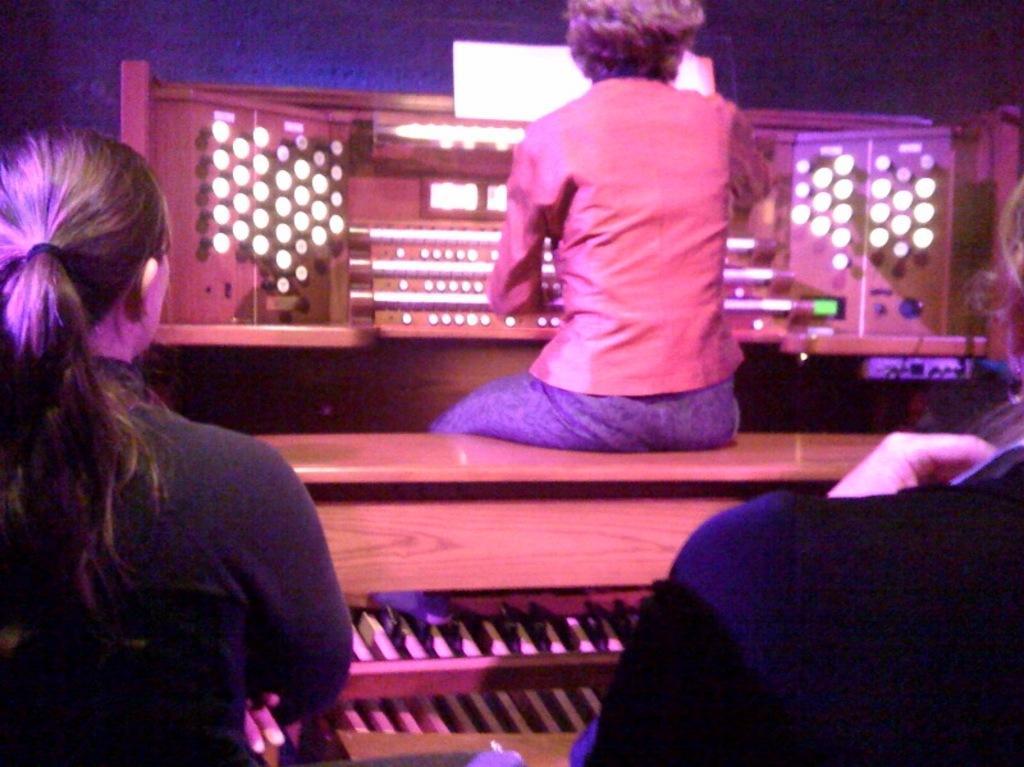Can you describe this image briefly? Here in the front we can see couple of women sitting on chairs over there and in front of them we can see a table, on which we can see another woman sitting and in front of her also we can see an electrical equipment present over there. 